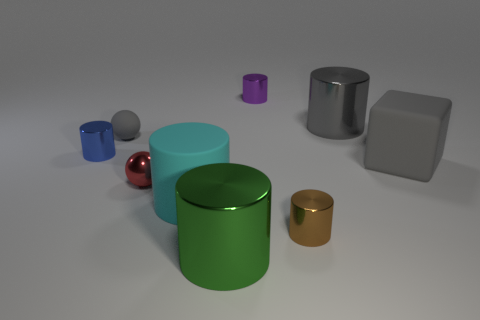There is a cylinder that is the same color as the small matte object; what is its material?
Offer a terse response. Metal. Is the number of metal things behind the tiny brown object greater than the number of large blue metallic cylinders?
Your response must be concise. Yes. Is the number of red metallic things that are in front of the cyan rubber cylinder the same as the number of things that are right of the brown cylinder?
Give a very brief answer. No. The small cylinder that is behind the big matte cylinder and right of the blue metallic cylinder is what color?
Ensure brevity in your answer.  Purple. Is the number of small objects that are in front of the blue metallic cylinder greater than the number of large green cylinders behind the large rubber cube?
Make the answer very short. Yes. Do the gray rubber thing left of the green metal thing and the red object have the same size?
Provide a short and direct response. Yes. There is a big metal thing that is behind the big rubber object that is to the right of the brown cylinder; what number of balls are on the right side of it?
Provide a short and direct response. 0. There is a shiny cylinder that is behind the tiny gray rubber thing and on the right side of the tiny purple metal cylinder; how big is it?
Ensure brevity in your answer.  Large. What number of other objects are the same shape as the tiny purple object?
Offer a very short reply. 5. There is a large green cylinder; how many tiny balls are on the right side of it?
Your answer should be compact. 0. 